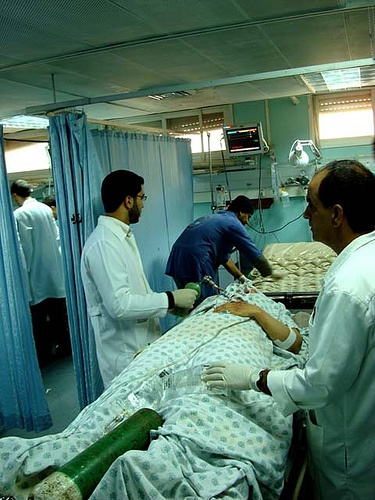Describe the objects in this image and their specific colors. I can see people in black, turquoise, and teal tones, people in black, darkgreen, and teal tones, people in black, teal, and lightblue tones, people in black and teal tones, and people in black, navy, blue, and teal tones in this image. 